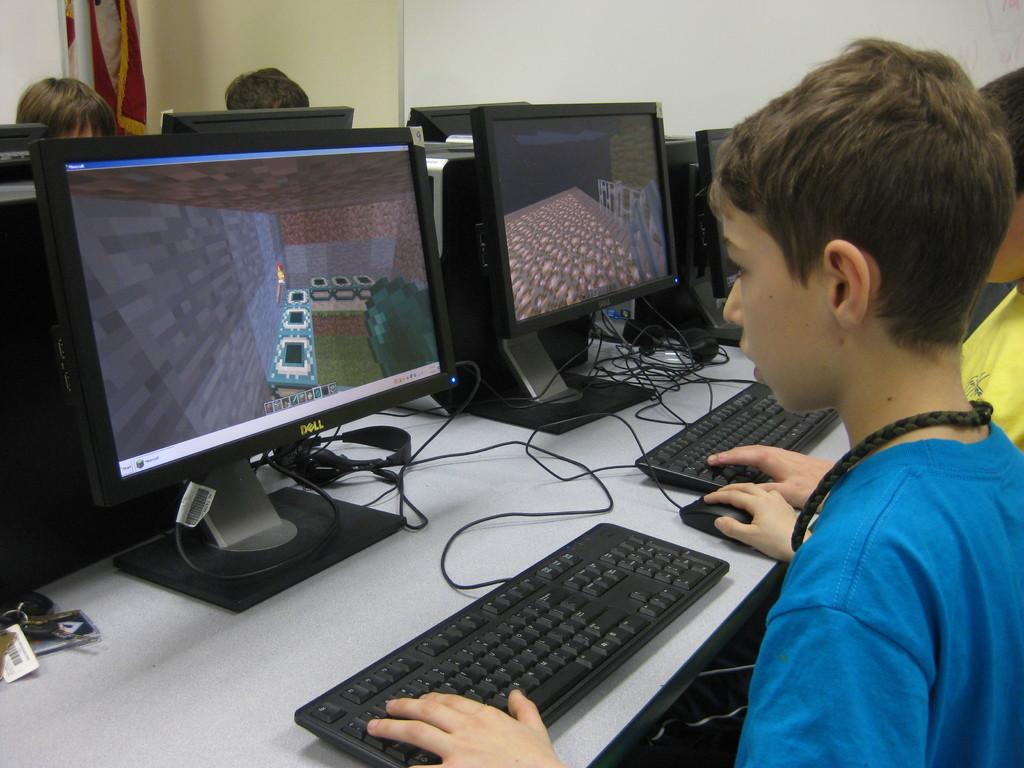Provide a one-sentence caption for the provided image. Two young boys are playing Minecraft on Dell computers. 